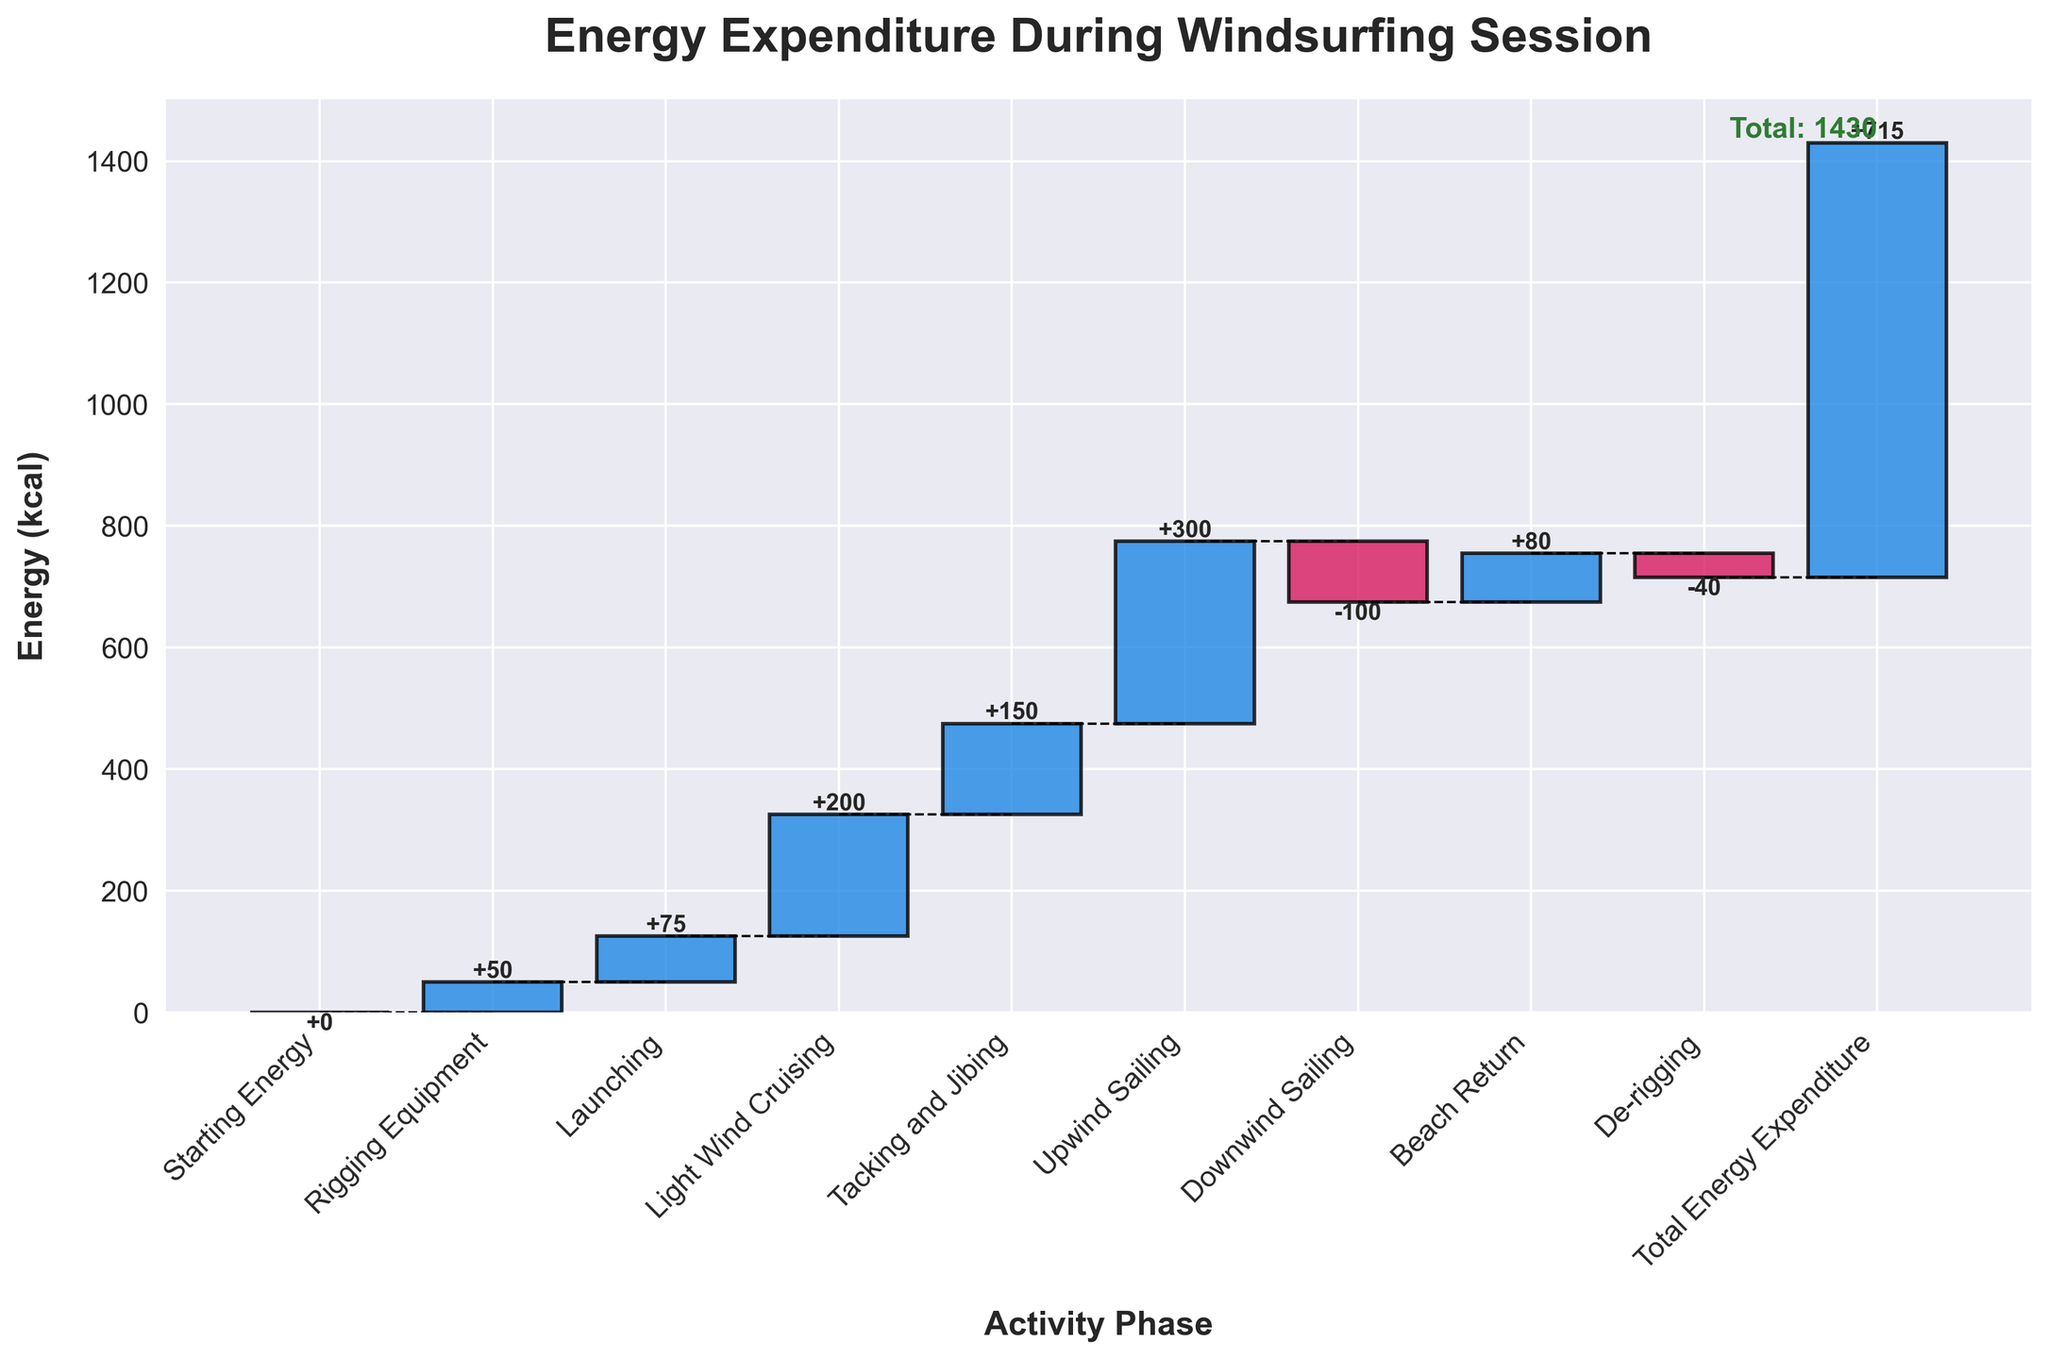what's the title of the chart? The title is located at the top of the chart, which indicates what the chart represents.
Answer: Energy Expenditure During Windsurfing Session how many activity phases are there in the chart? Count the number of bars in the chart to determine the number of activity phases.
Answer: 9 which activity phase has the highest energy expenditure? Look for the bar with the largest positive value in terms of height in the chart.
Answer: Upwind Sailing which activity phase results in a significant reduction in energy expenditure? Locate the bar with the largest negative value in the chart.
Answer: Downwind Sailing what is the total energy expenditure by the end of the session? The total energy expenditure is marked at the end of the chart, often highlighted or described.
Answer: 715 how much energy is expended during "Light Wind Cruising" and "Tacking and Jibing" combined? Sum up the energy values for "Light Wind Cruising" (200 kcal) and "Tacking and Jibing" (150 kcal). 200 + 150 = 350
Answer: 350 is the energy expended for "Rigging Equipment" greater than for "Launching"? Compare the heights of the bars for "Rigging Equipment" (50 kcal) and "Launching" (75 kcal). 50 < 75
Answer: No how does the energy expenditure for "Beach Return" compare to "De-rigging"? Compare the values associated with "Beach Return" (80 kcal) and "De-rigging" (-40 kcal). 80 > -40
Answer: Beach Return has higher energy expenditure which activity results in a decrease in energy expenditure? Identify the bars with negative values by their direction and color (e.g., De-rigging and Downwind Sailing).
Answer: Downwind Sailing and De-rigging how much does the energy expenditure increase from "Launching" to "Light Wind Cruising"? Find the difference in cumulative energy between "Launching" and "Light Wind Cruising". 75 + 200 - 75 = 200
Answer: 200 